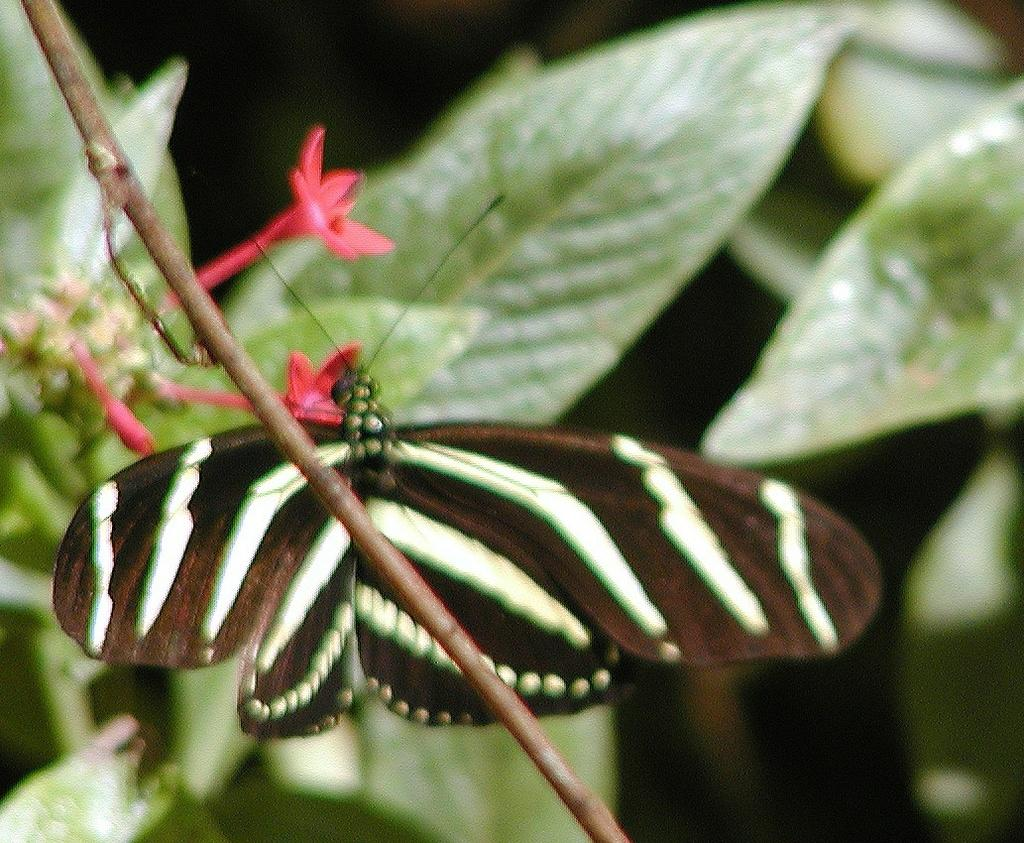What is present in the image that is flying? There is a butterfly in the image that is flying. Where is the butterfly located in the image? The butterfly is on a plant. How many maids are serving food in the image? There are no maids present in the image; it features a butterfly on a plant. 